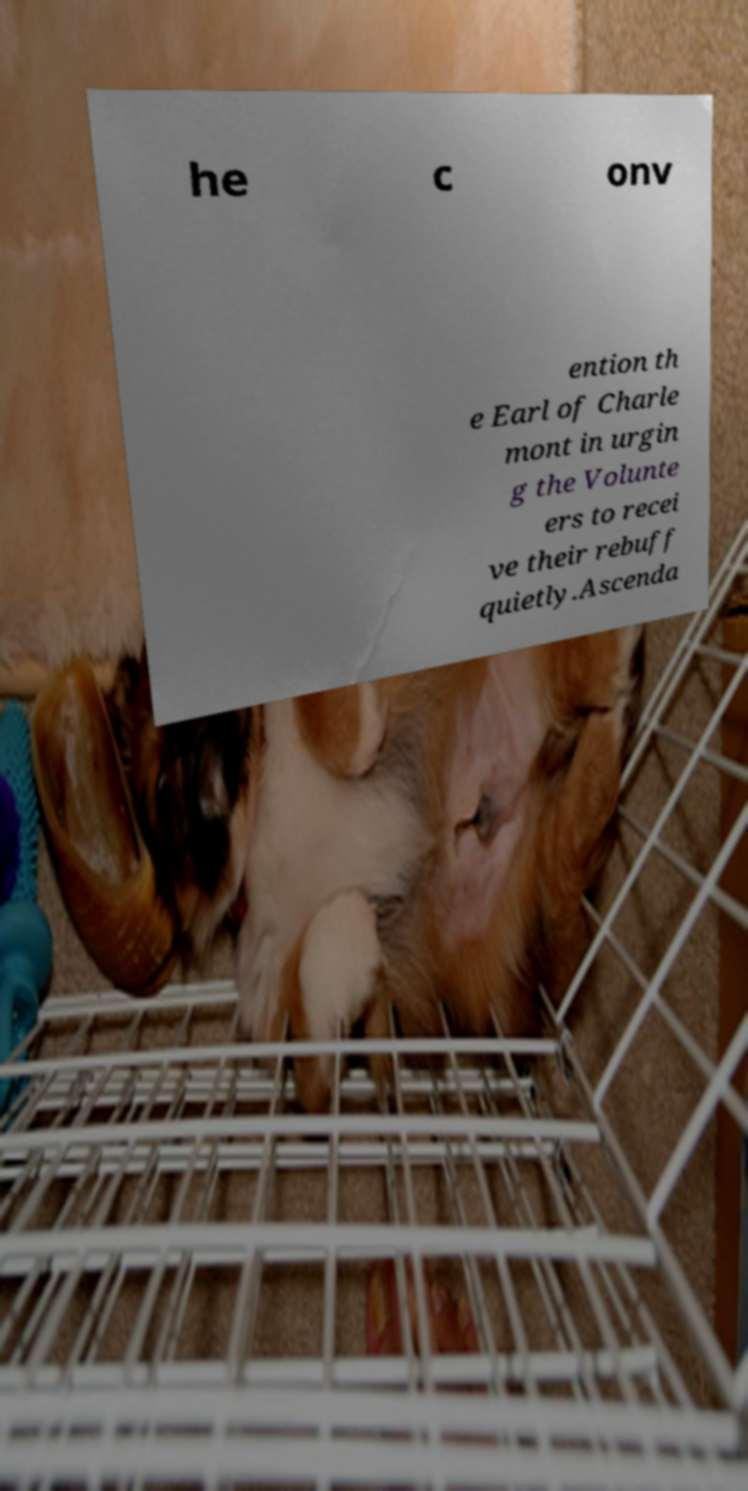Could you assist in decoding the text presented in this image and type it out clearly? he c onv ention th e Earl of Charle mont in urgin g the Volunte ers to recei ve their rebuff quietly.Ascenda 